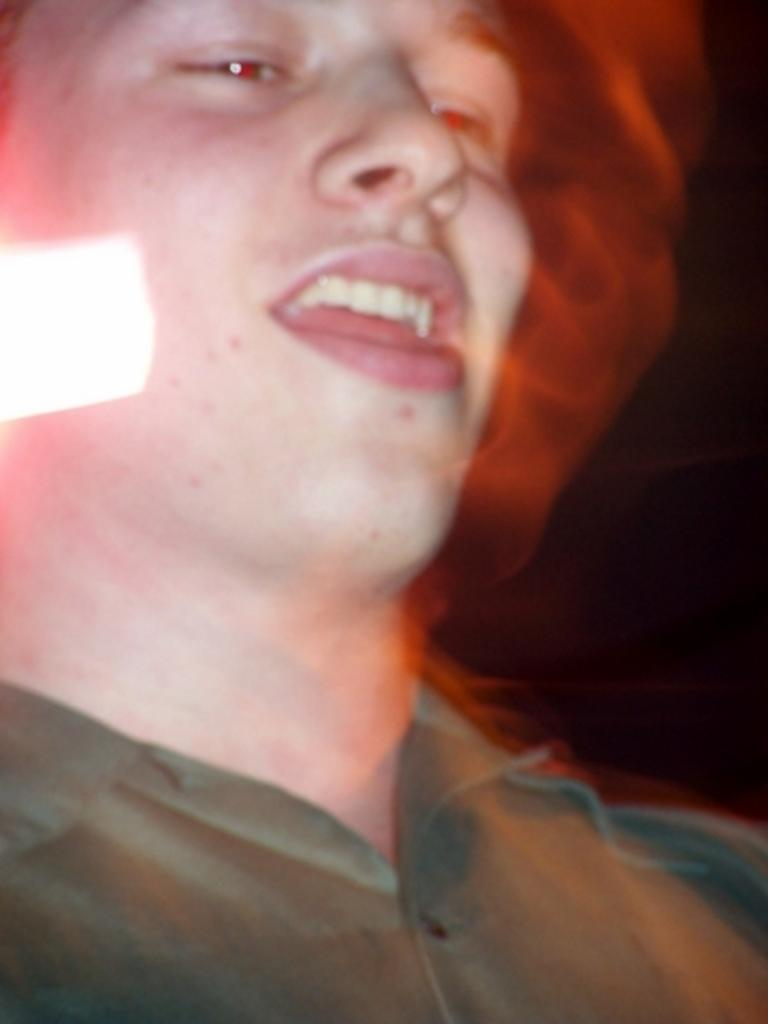Who or what is the main subject in the image? There is a person in the image. What can be observed about the background of the image? The background of the image is black in color. How many trucks are visible in the image? There are no trucks present in the image. What type of legs can be seen in the image? There is no reference to legs in the image, as it features a person against a black background. 